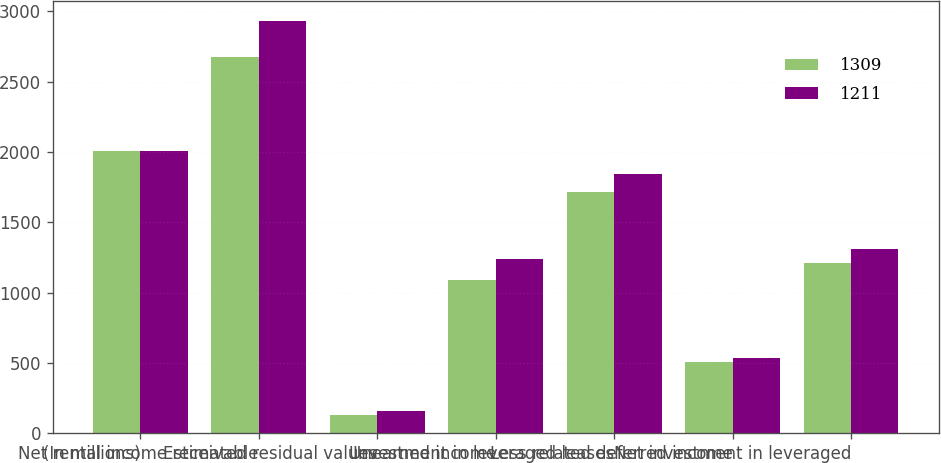Convert chart to OTSL. <chart><loc_0><loc_0><loc_500><loc_500><stacked_bar_chart><ecel><fcel>(In millions)<fcel>Net rental income receivable<fcel>Estimated residual values<fcel>Unearned income<fcel>Investment in leveraged leases<fcel>Less related deferred income<fcel>Net investment in leveraged<nl><fcel>1309<fcel>2009<fcel>2677<fcel>129<fcel>1090<fcel>1716<fcel>505<fcel>1211<nl><fcel>1211<fcel>2008<fcel>2929<fcel>156<fcel>1241<fcel>1844<fcel>535<fcel>1309<nl></chart> 